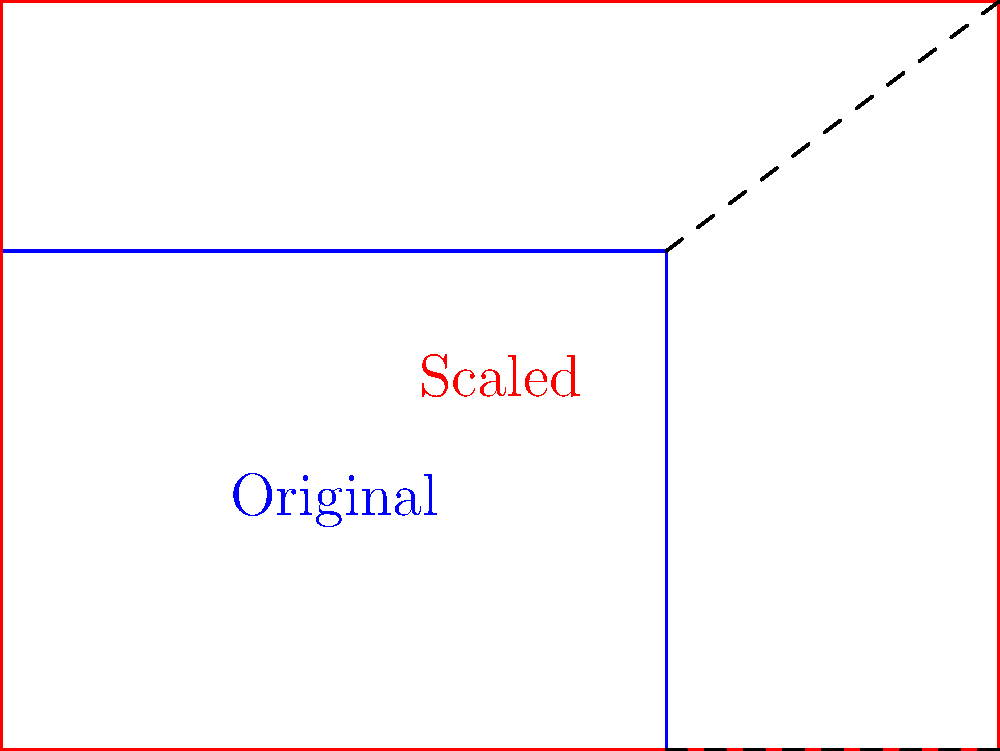You're working on a group cosplay project and need to scale up a rectangular costume pattern. The original pattern measures 4 units wide and 3 units tall. If you need to increase the width to 6 units while maintaining the aspect ratio, what will be the new height of the pattern? Express your answer in terms of units. To solve this problem, we'll use the concept of vector scaling and aspect ratio preservation:

1. Original dimensions: 4 units wide, 3 units tall
2. New width: 6 units

Let's find the scaling factor:
3. Scaling factor = New width / Original width
   $$ \text{Scaling factor} = \frac{6}{4} = 1.5 $$

4. To maintain the aspect ratio, we must apply this scaling factor to both dimensions.

5. New height calculation:
   $$ \text{New height} = \text{Original height} \times \text{Scaling factor} $$
   $$ \text{New height} = 3 \times 1.5 = 4.5 \text{ units} $$

Therefore, the new height of the pattern will be 4.5 units.
Answer: 4.5 units 